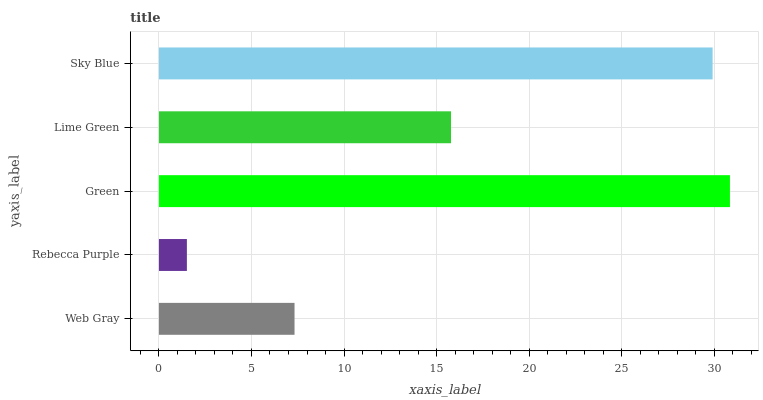Is Rebecca Purple the minimum?
Answer yes or no. Yes. Is Green the maximum?
Answer yes or no. Yes. Is Green the minimum?
Answer yes or no. No. Is Rebecca Purple the maximum?
Answer yes or no. No. Is Green greater than Rebecca Purple?
Answer yes or no. Yes. Is Rebecca Purple less than Green?
Answer yes or no. Yes. Is Rebecca Purple greater than Green?
Answer yes or no. No. Is Green less than Rebecca Purple?
Answer yes or no. No. Is Lime Green the high median?
Answer yes or no. Yes. Is Lime Green the low median?
Answer yes or no. Yes. Is Web Gray the high median?
Answer yes or no. No. Is Sky Blue the low median?
Answer yes or no. No. 